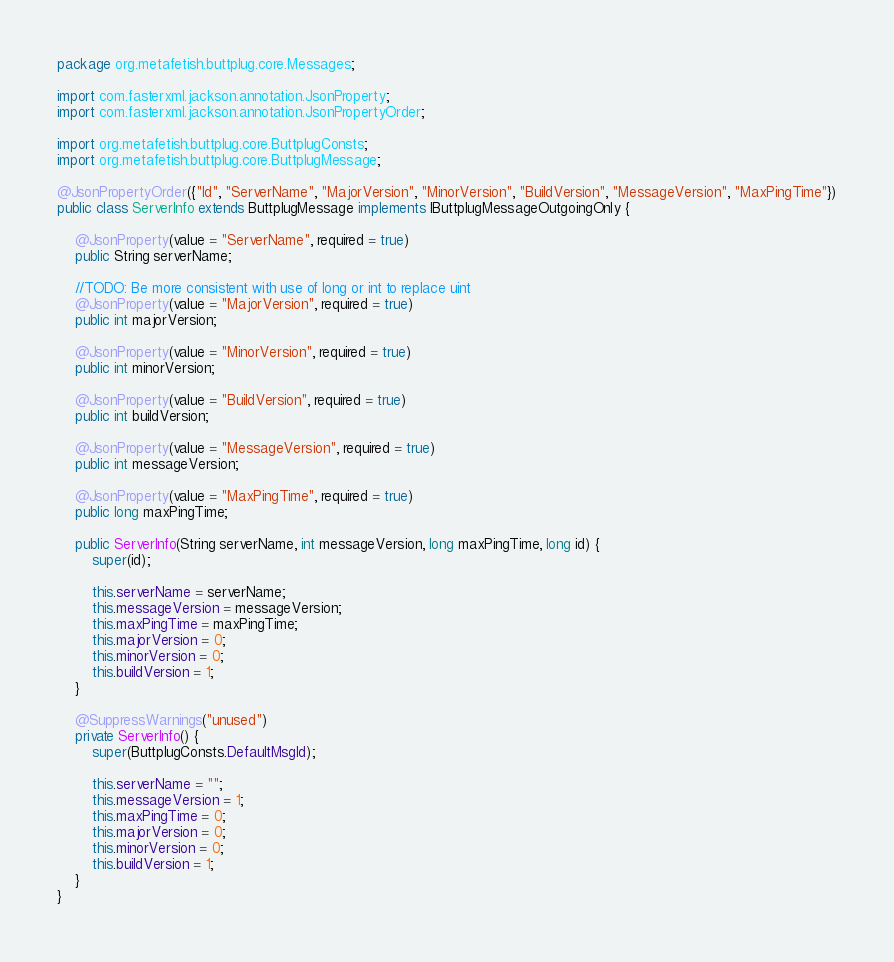<code> <loc_0><loc_0><loc_500><loc_500><_Java_>package org.metafetish.buttplug.core.Messages;

import com.fasterxml.jackson.annotation.JsonProperty;
import com.fasterxml.jackson.annotation.JsonPropertyOrder;

import org.metafetish.buttplug.core.ButtplugConsts;
import org.metafetish.buttplug.core.ButtplugMessage;

@JsonPropertyOrder({"Id", "ServerName", "MajorVersion", "MinorVersion", "BuildVersion", "MessageVersion", "MaxPingTime"})
public class ServerInfo extends ButtplugMessage implements IButtplugMessageOutgoingOnly {

    @JsonProperty(value = "ServerName", required = true)
    public String serverName;

    //TODO: Be more consistent with use of long or int to replace uint
    @JsonProperty(value = "MajorVersion", required = true)
    public int majorVersion;

    @JsonProperty(value = "MinorVersion", required = true)
    public int minorVersion;

    @JsonProperty(value = "BuildVersion", required = true)
    public int buildVersion;

    @JsonProperty(value = "MessageVersion", required = true)
    public int messageVersion;

    @JsonProperty(value = "MaxPingTime", required = true)
    public long maxPingTime;

    public ServerInfo(String serverName, int messageVersion, long maxPingTime, long id) {
        super(id);

        this.serverName = serverName;
        this.messageVersion = messageVersion;
        this.maxPingTime = maxPingTime;
        this.majorVersion = 0;
        this.minorVersion = 0;
        this.buildVersion = 1;
    }

    @SuppressWarnings("unused")
    private ServerInfo() {
        super(ButtplugConsts.DefaultMsgId);

        this.serverName = "";
        this.messageVersion = 1;
        this.maxPingTime = 0;
        this.majorVersion = 0;
        this.minorVersion = 0;
        this.buildVersion = 1;
    }
}</code> 